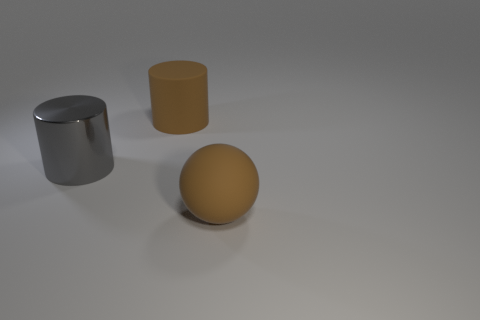Add 1 blue objects. How many objects exist? 4 Subtract all balls. How many objects are left? 2 Subtract all large matte spheres. Subtract all big metal objects. How many objects are left? 1 Add 1 rubber spheres. How many rubber spheres are left? 2 Add 1 big brown matte cylinders. How many big brown matte cylinders exist? 2 Subtract 0 cyan cylinders. How many objects are left? 3 